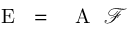<formula> <loc_0><loc_0><loc_500><loc_500>{ E } = { A } \mathcal { F }</formula> 